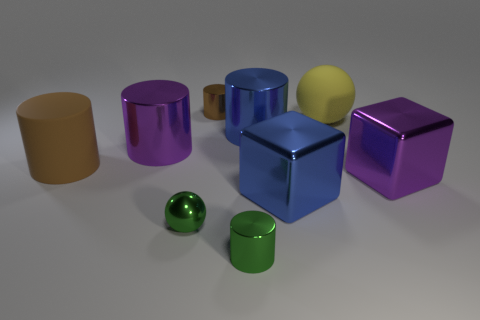Subtract all big blue metallic cylinders. How many cylinders are left? 4 Subtract all purple cylinders. How many cylinders are left? 4 Subtract all gray cylinders. Subtract all red spheres. How many cylinders are left? 5 Subtract all cubes. How many objects are left? 7 Add 4 purple cylinders. How many purple cylinders exist? 5 Subtract 0 purple spheres. How many objects are left? 9 Subtract all small purple cylinders. Subtract all purple cylinders. How many objects are left? 8 Add 5 tiny brown metal objects. How many tiny brown metal objects are left? 6 